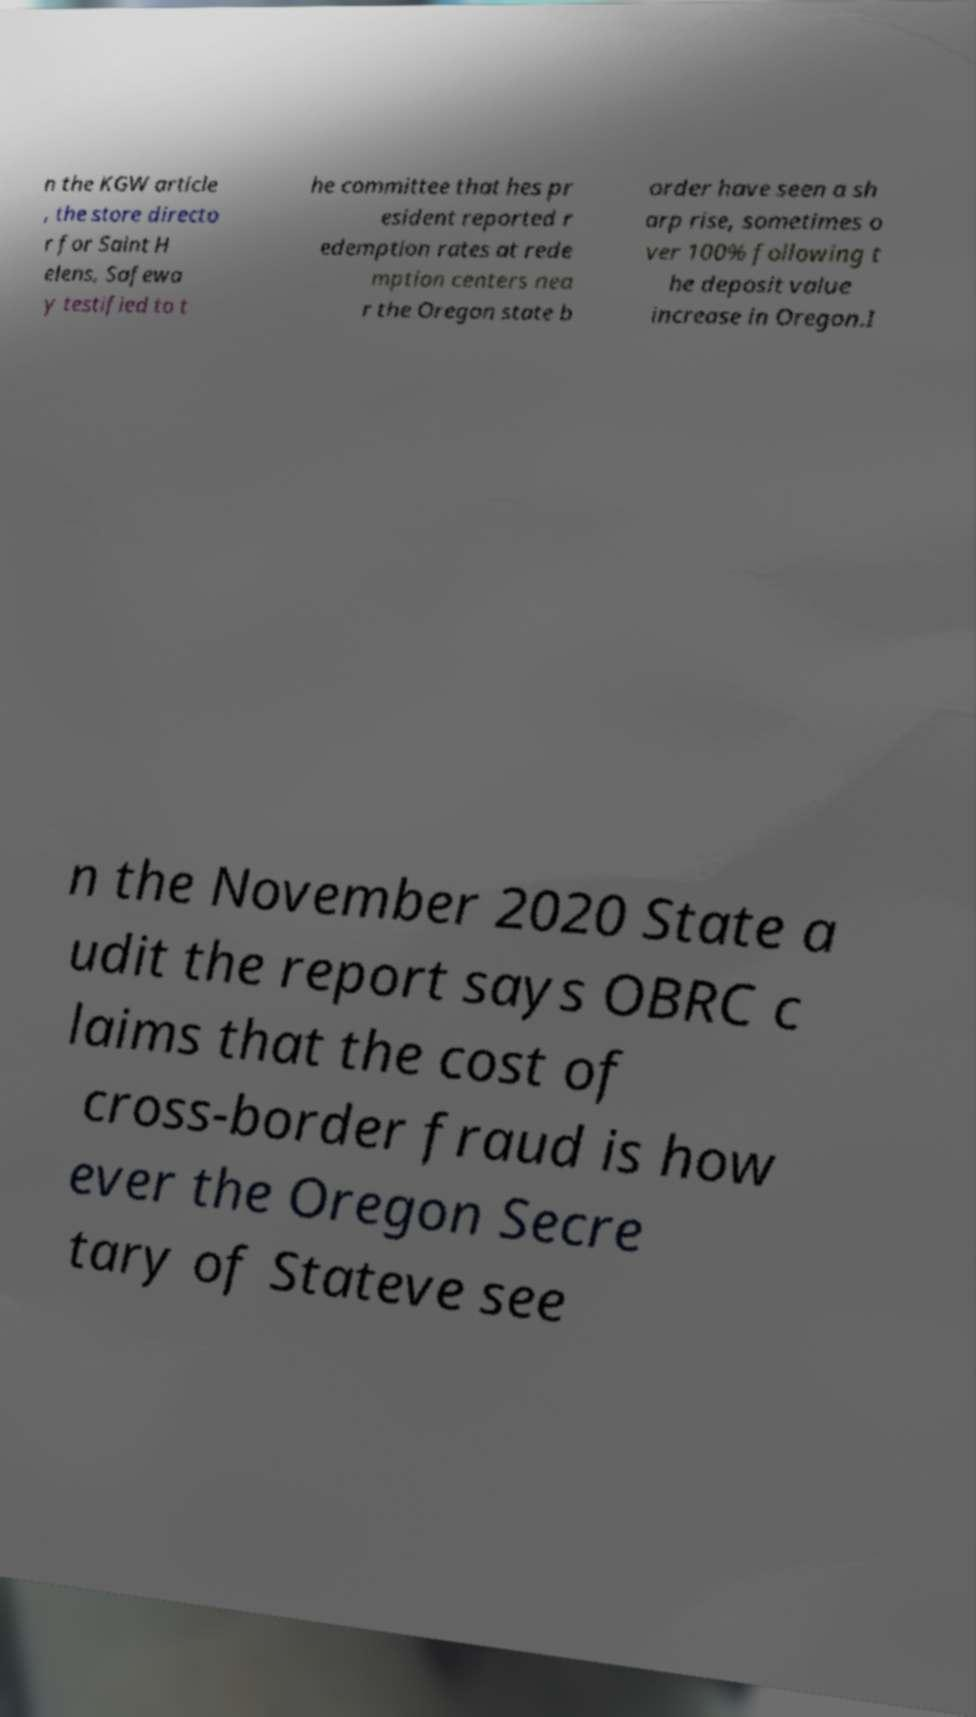I need the written content from this picture converted into text. Can you do that? n the KGW article , the store directo r for Saint H elens, Safewa y testified to t he committee that hes pr esident reported r edemption rates at rede mption centers nea r the Oregon state b order have seen a sh arp rise, sometimes o ver 100% following t he deposit value increase in Oregon.I n the November 2020 State a udit the report says OBRC c laims that the cost of cross-border fraud is how ever the Oregon Secre tary of Stateve see 